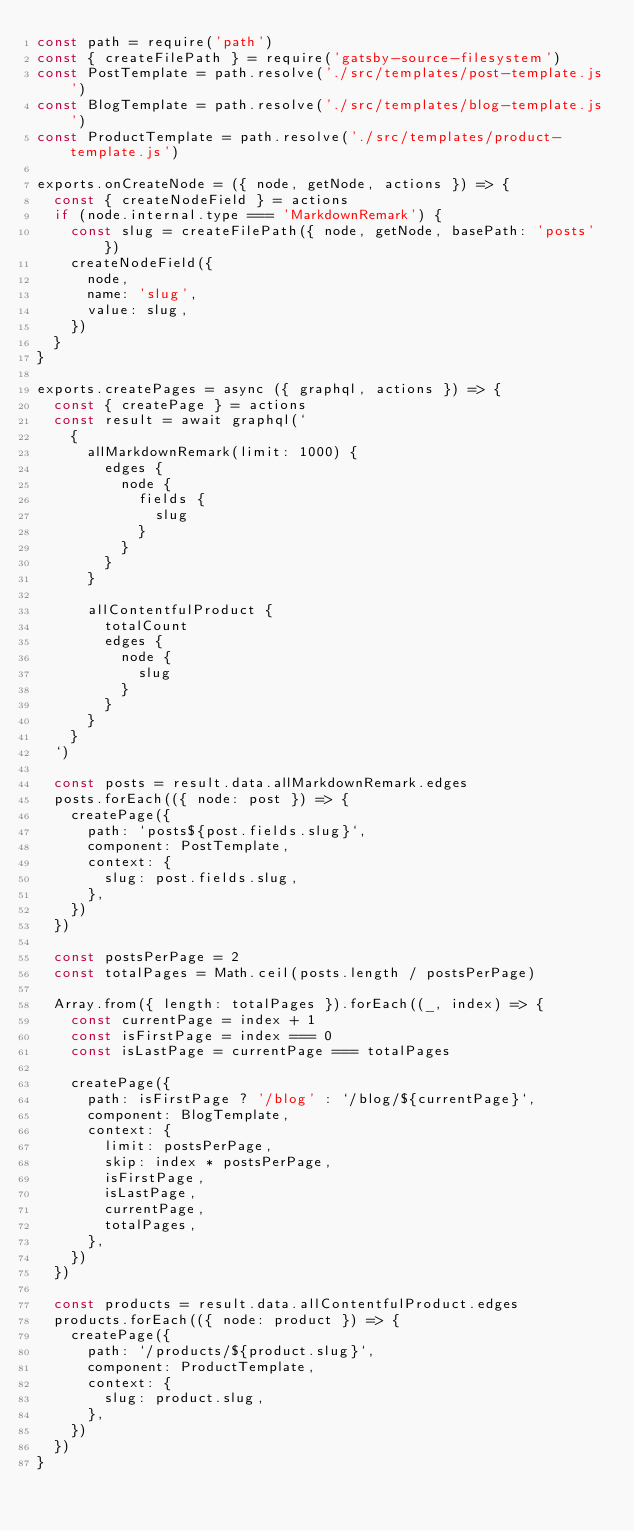<code> <loc_0><loc_0><loc_500><loc_500><_JavaScript_>const path = require('path')
const { createFilePath } = require('gatsby-source-filesystem')
const PostTemplate = path.resolve('./src/templates/post-template.js')
const BlogTemplate = path.resolve('./src/templates/blog-template.js')
const ProductTemplate = path.resolve('./src/templates/product-template.js')

exports.onCreateNode = ({ node, getNode, actions }) => {
  const { createNodeField } = actions
  if (node.internal.type === 'MarkdownRemark') {
    const slug = createFilePath({ node, getNode, basePath: 'posts' })
    createNodeField({
      node,
      name: 'slug',
      value: slug,
    })
  }
}

exports.createPages = async ({ graphql, actions }) => {
  const { createPage } = actions
  const result = await graphql(`
    {
      allMarkdownRemark(limit: 1000) {
        edges {
          node {
            fields {
              slug
            }
          }
        }
      }

      allContentfulProduct {
        totalCount
        edges {
          node {
            slug
          }
        }
      }
    }
  `)

  const posts = result.data.allMarkdownRemark.edges
  posts.forEach(({ node: post }) => {
    createPage({
      path: `posts${post.fields.slug}`,
      component: PostTemplate,
      context: {
        slug: post.fields.slug,
      },
    })
  })

  const postsPerPage = 2
  const totalPages = Math.ceil(posts.length / postsPerPage)

  Array.from({ length: totalPages }).forEach((_, index) => {
    const currentPage = index + 1
    const isFirstPage = index === 0
    const isLastPage = currentPage === totalPages

    createPage({
      path: isFirstPage ? '/blog' : `/blog/${currentPage}`,
      component: BlogTemplate,
      context: {
        limit: postsPerPage,
        skip: index * postsPerPage,
        isFirstPage,
        isLastPage,
        currentPage,
        totalPages,
      },
    })
  })

  const products = result.data.allContentfulProduct.edges
  products.forEach(({ node: product }) => {
    createPage({
      path: `/products/${product.slug}`,
      component: ProductTemplate,
      context: {
        slug: product.slug,
      },
    })
  })
}
</code> 